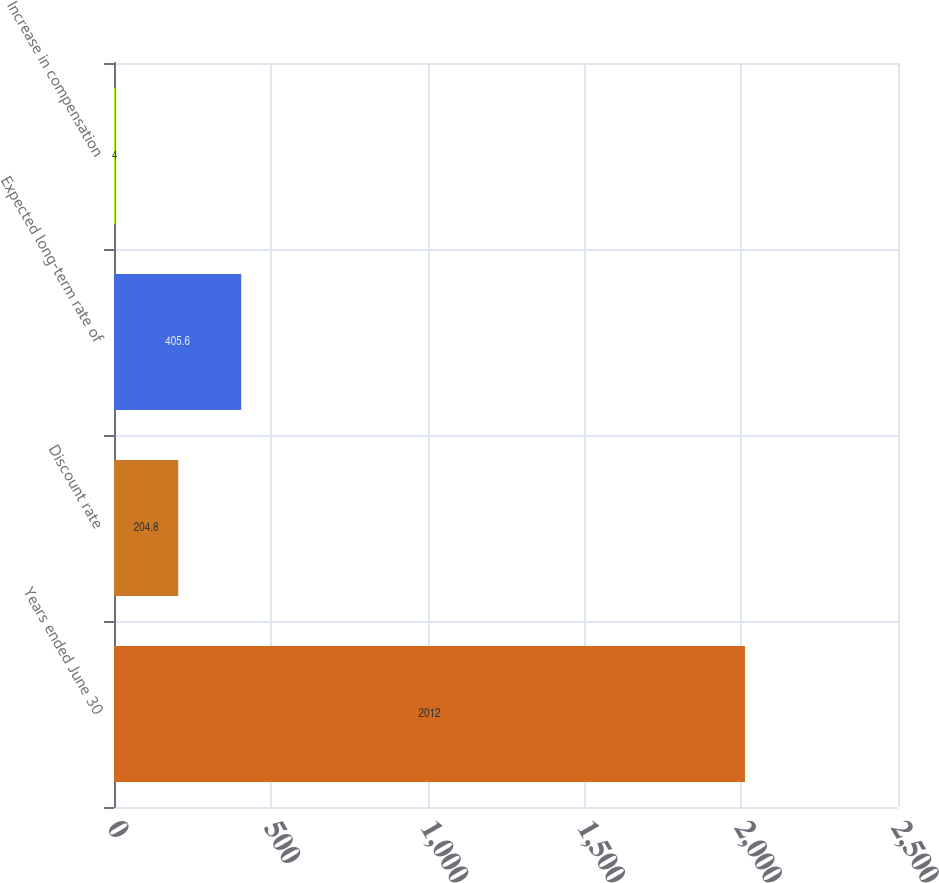Convert chart to OTSL. <chart><loc_0><loc_0><loc_500><loc_500><bar_chart><fcel>Years ended June 30<fcel>Discount rate<fcel>Expected long-term rate of<fcel>Increase in compensation<nl><fcel>2012<fcel>204.8<fcel>405.6<fcel>4<nl></chart> 